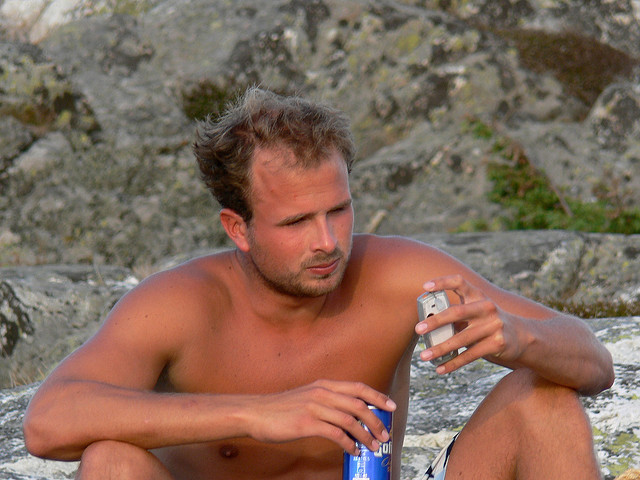<image>Has it been more than one month or less than one week since this man has shaved? It is unknown if it has been more than one month or less than one week since this man has shaved. Has it been more than one month or less than one week since this man has shaved? It is unanswerable whether it has been more than one month or less than one week since this man has shaved. 